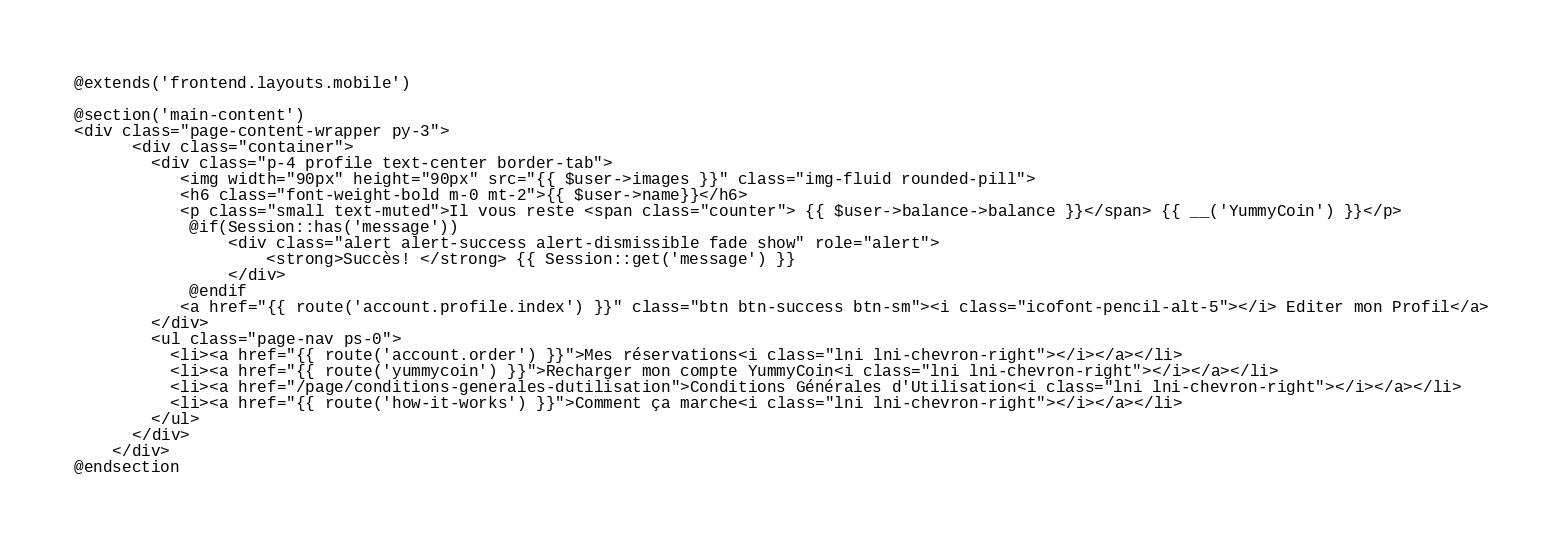<code> <loc_0><loc_0><loc_500><loc_500><_PHP_>@extends('frontend.layouts.mobile')

@section('main-content')
<div class="page-content-wrapper py-3">
      <div class="container">
        <div class="p-4 profile text-center border-tab">
           <img width="90px" height="90px" src="{{ $user->images }}" class="img-fluid rounded-pill">
           <h6 class="font-weight-bold m-0 mt-2">{{ $user->name}}</h6>
           <p class="small text-muted">Il vous reste <span class="counter"> {{ $user->balance->balance }}</span> {{ __('YummyCoin') }}</p>
            @if(Session::has('message'))
                <div class="alert alert-success alert-dismissible fade show" role="alert">
                    <strong>Succès! </strong> {{ Session::get('message') }}
                </div>
            @endif
           <a href="{{ route('account.profile.index') }}" class="btn btn-success btn-sm"><i class="icofont-pencil-alt-5"></i> Editer mon Profil</a>
        </div>
        <ul class="page-nav ps-0">
          <li><a href="{{ route('account.order') }}">Mes réservations<i class="lni lni-chevron-right"></i></a></li>
          <li><a href="{{ route('yummycoin') }}">Recharger mon compte YummyCoin<i class="lni lni-chevron-right"></i></a></li>
          <li><a href="/page/conditions-generales-dutilisation">Conditions Générales d'Utilisation<i class="lni lni-chevron-right"></i></a></li>
          <li><a href="{{ route('how-it-works') }}">Comment ça marche<i class="lni lni-chevron-right"></i></a></li>
        </ul>
      </div>
    </div>
@endsection
</code> 